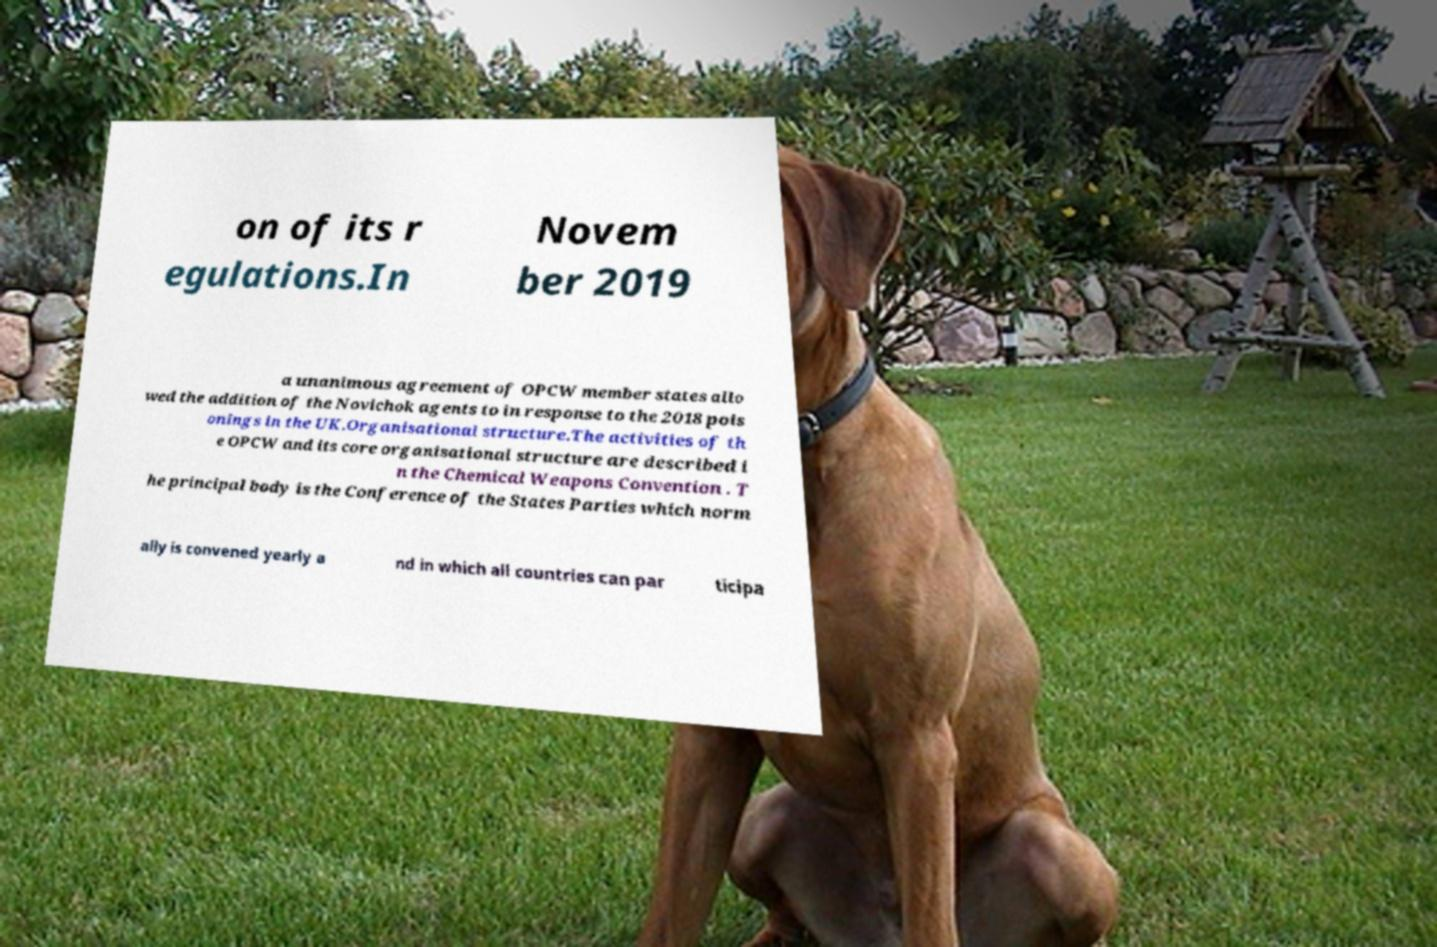What messages or text are displayed in this image? I need them in a readable, typed format. on of its r egulations.In Novem ber 2019 a unanimous agreement of OPCW member states allo wed the addition of the Novichok agents to in response to the 2018 pois onings in the UK.Organisational structure.The activities of th e OPCW and its core organisational structure are described i n the Chemical Weapons Convention . T he principal body is the Conference of the States Parties which norm ally is convened yearly a nd in which all countries can par ticipa 